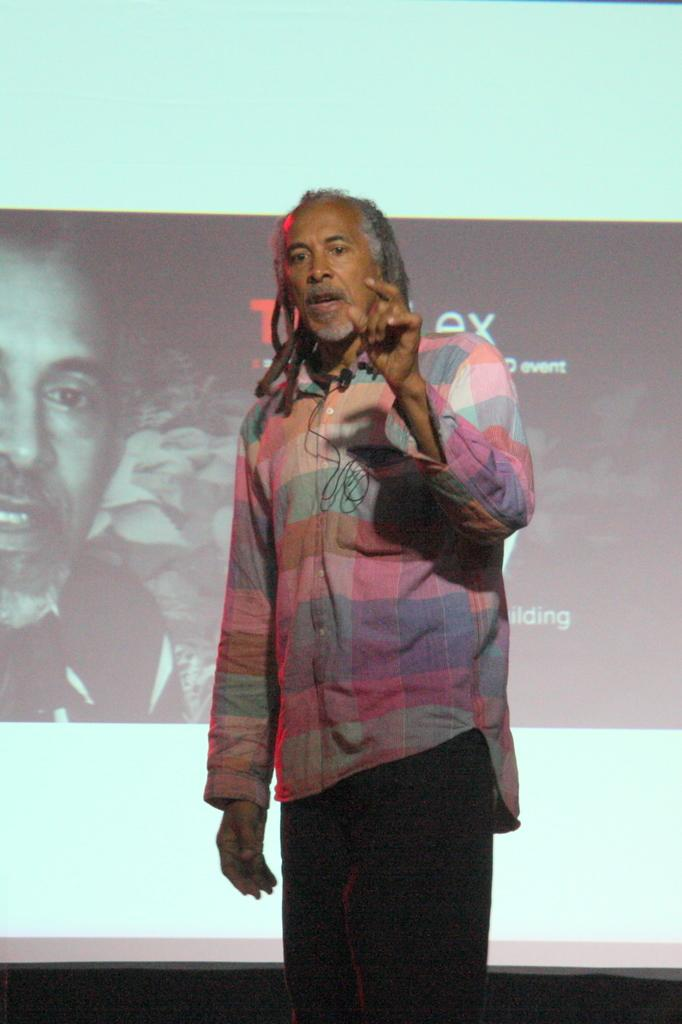What is present in the image that displays information or visuals? There is a screen in the image. Can you describe the person in the image? There is a man standing in the image. What type of bean is being advertised on the screen in the image? There is no bean or advertisement present in the image; it only features a screen and a man standing. What does the taste of the bean being advertised on the screen in the image suggest about its flavor? There is no bean or advertisement present in the image, so it is not possible to determine its taste or flavor. 